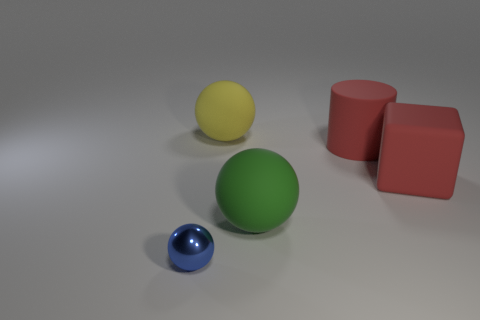Is there anything else that is the same material as the tiny blue thing?
Give a very brief answer. No. There is a large red rubber thing behind the big block that is on the right side of the rubber sphere that is in front of the big yellow matte object; what is its shape?
Give a very brief answer. Cylinder. The object that is both in front of the big red matte cube and on the right side of the tiny blue metallic ball is what color?
Your response must be concise. Green. The big matte thing on the left side of the big green ball has what shape?
Provide a short and direct response. Sphere. What shape is the green thing that is made of the same material as the large yellow ball?
Make the answer very short. Sphere. What number of rubber things are yellow spheres or green things?
Ensure brevity in your answer.  2. What number of big blocks are left of the sphere on the right side of the sphere behind the green object?
Ensure brevity in your answer.  0. There is a matte sphere that is in front of the yellow matte thing; does it have the same size as the rubber ball behind the big red block?
Provide a succinct answer. Yes. What is the material of the other tiny object that is the same shape as the yellow thing?
Keep it short and to the point. Metal. What number of tiny objects are either matte cylinders or red cubes?
Keep it short and to the point. 0. 